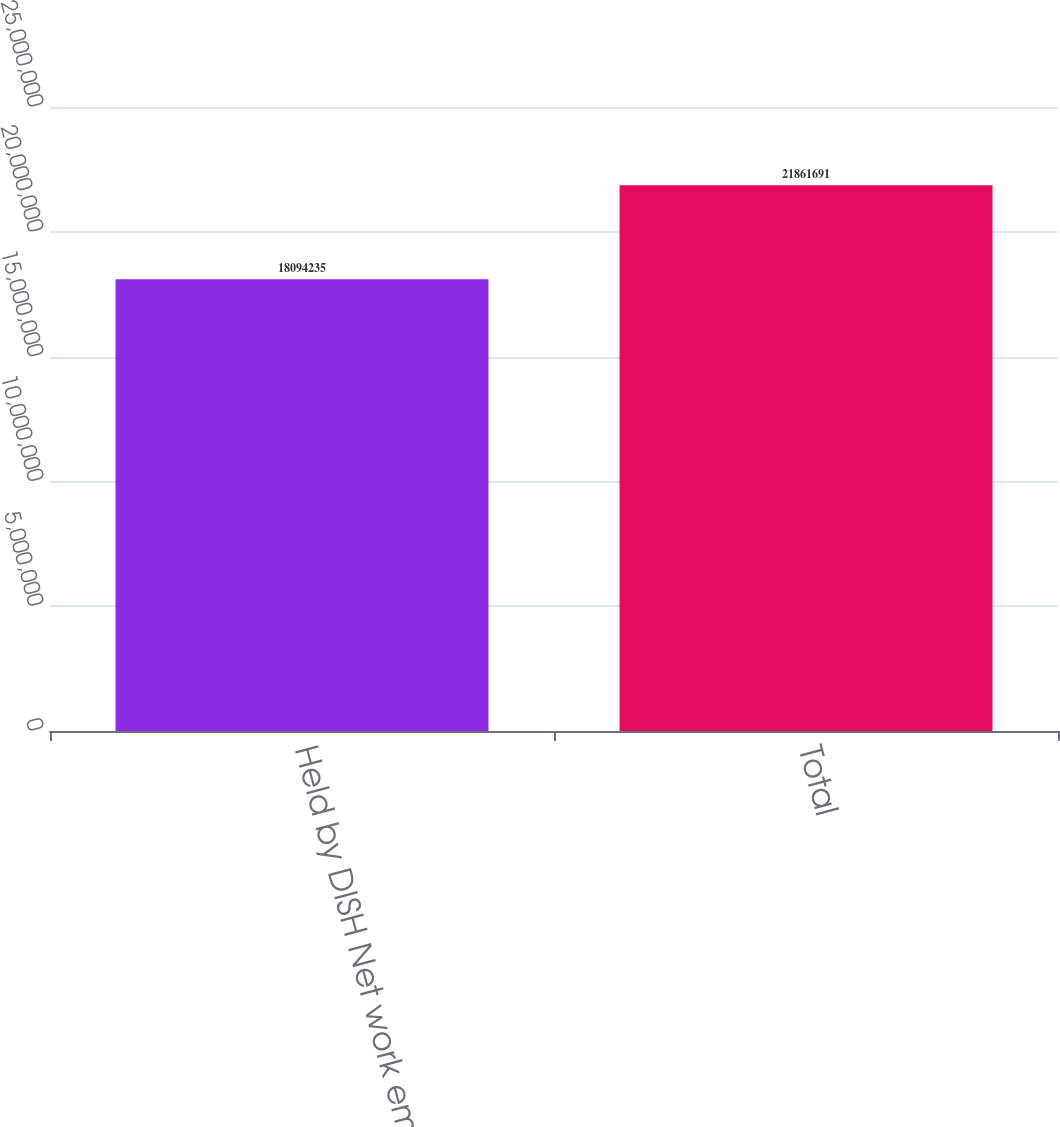<chart> <loc_0><loc_0><loc_500><loc_500><bar_chart><fcel>Held by DISH Net work empl<fcel>Total<nl><fcel>1.80942e+07<fcel>2.18617e+07<nl></chart> 